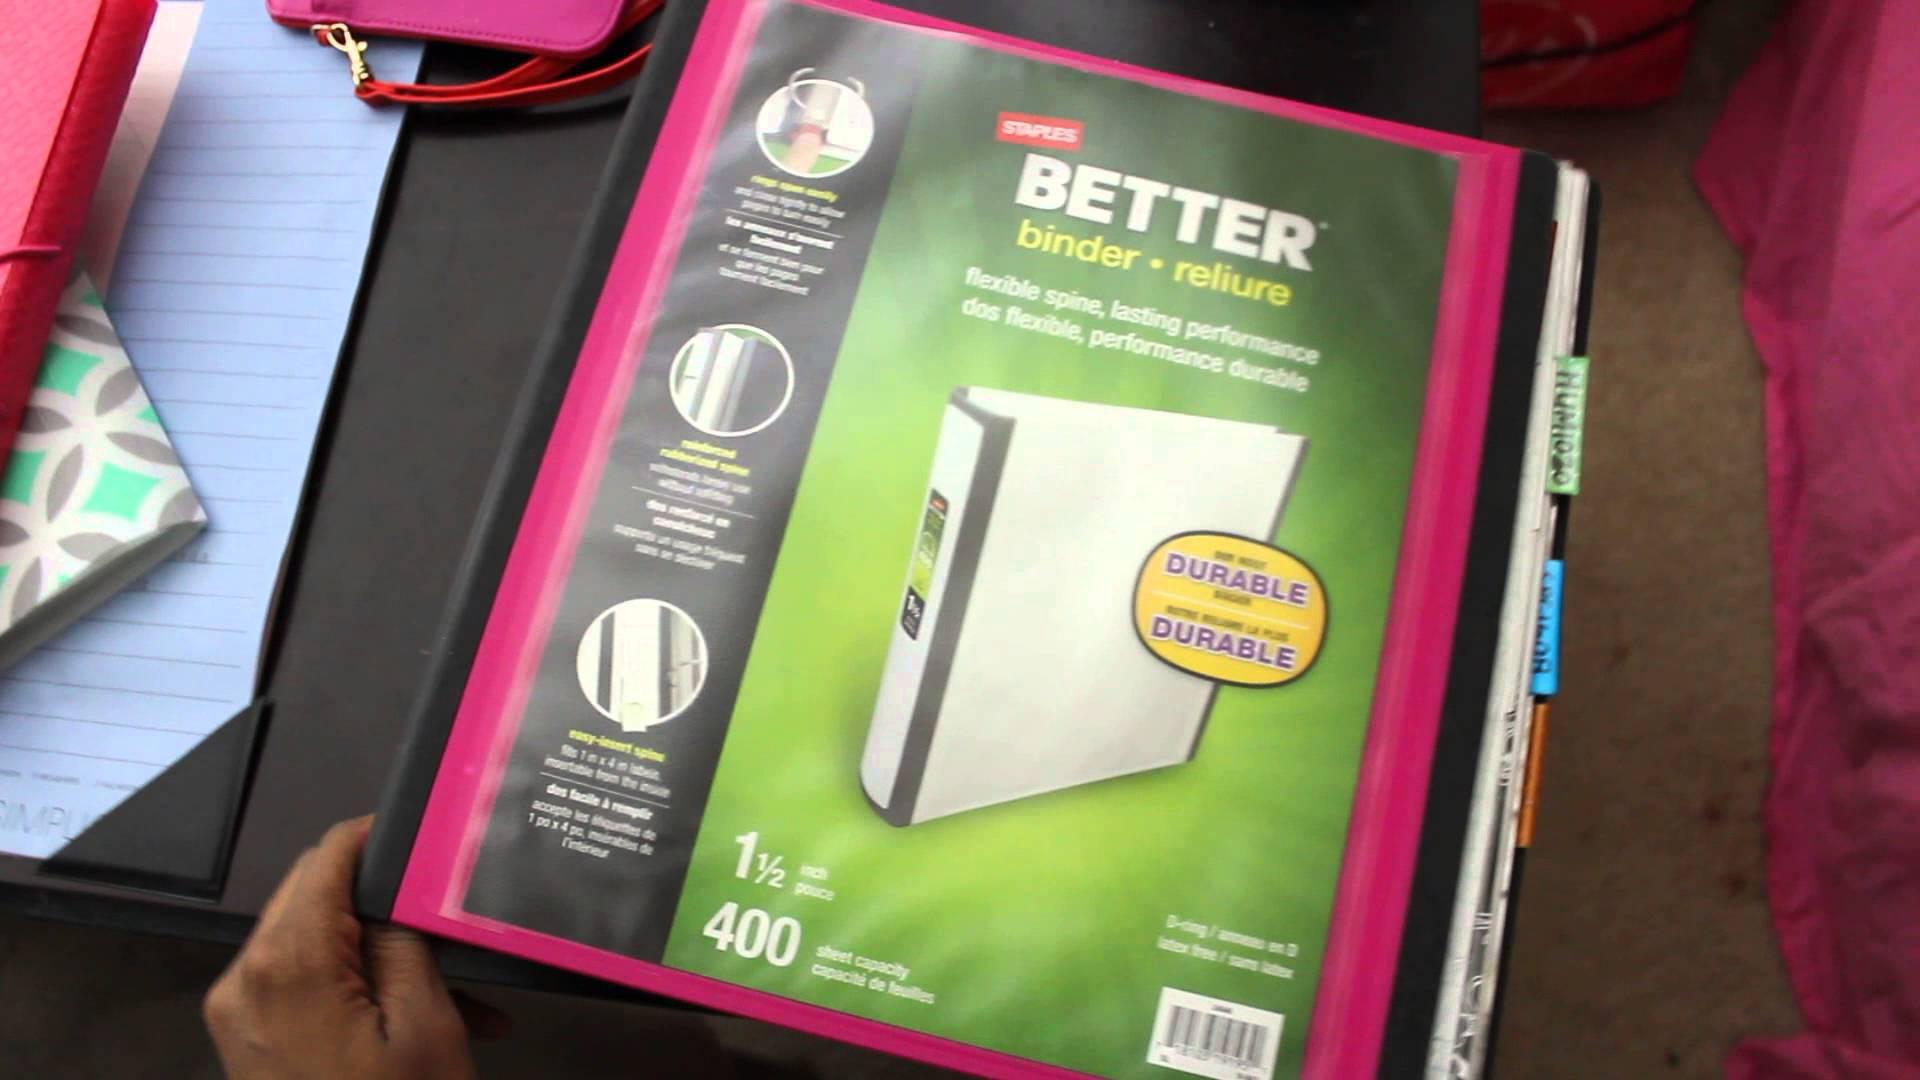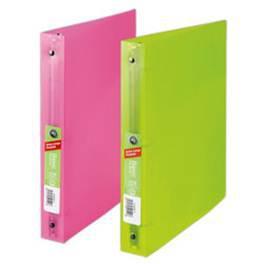The first image is the image on the left, the second image is the image on the right. For the images displayed, is the sentence "There are four binders in the image on the right." factually correct? Answer yes or no. No. 